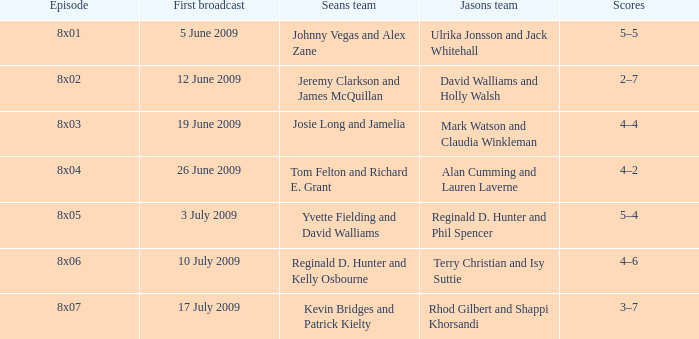Who was on Jason's team in the episode where Sean's team was Reginald D. Hunter and Kelly Osbourne? Terry Christian and Isy Suttie. 